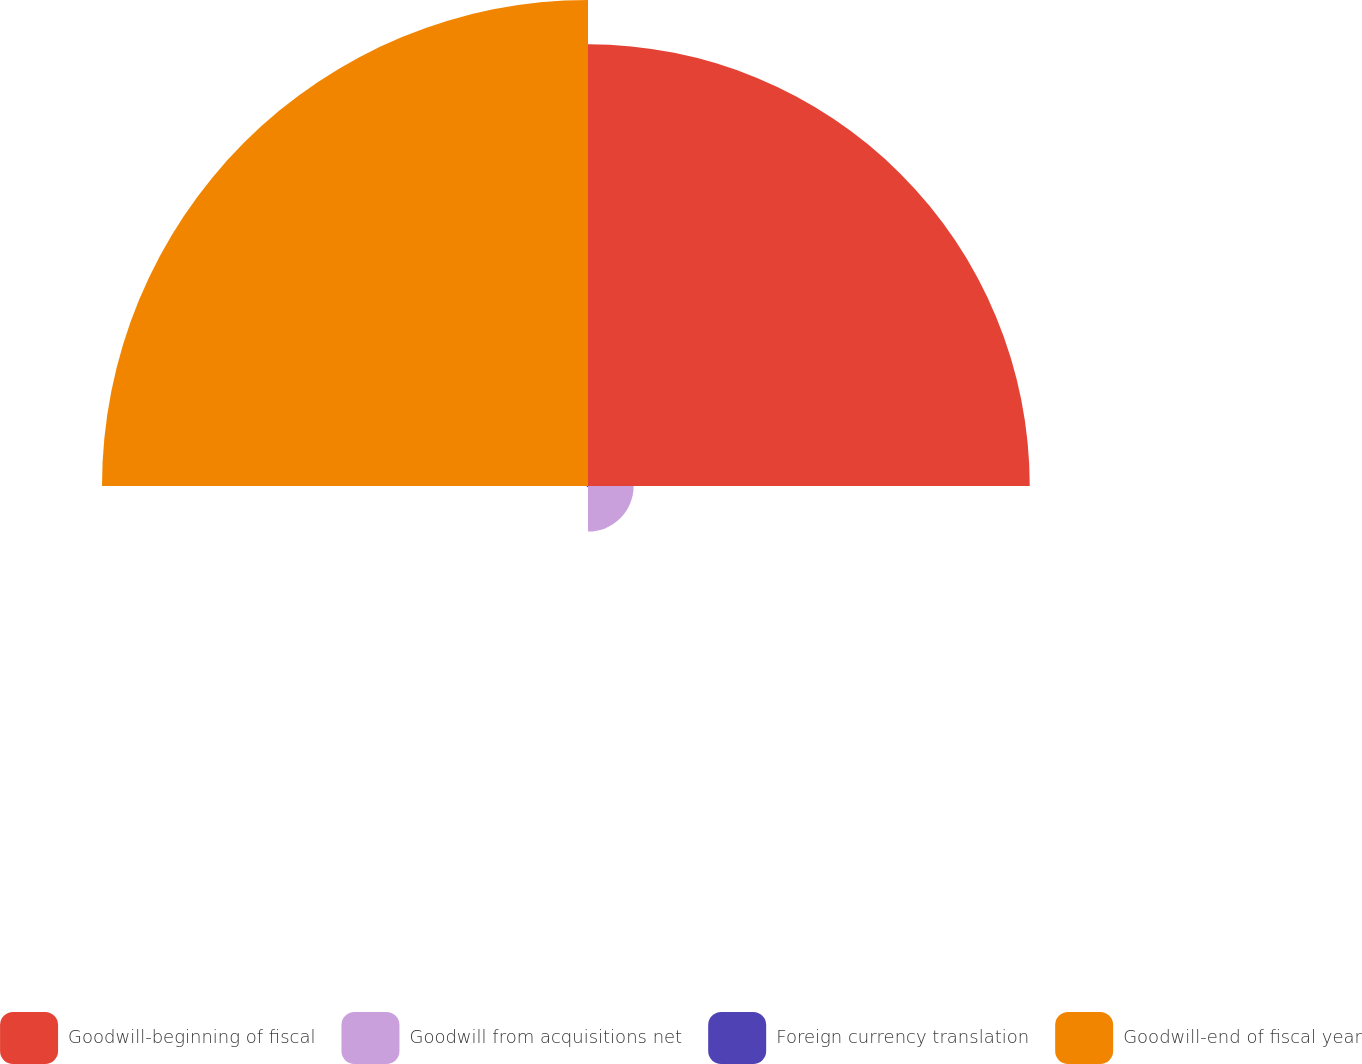<chart> <loc_0><loc_0><loc_500><loc_500><pie_chart><fcel>Goodwill-beginning of fiscal<fcel>Goodwill from acquisitions net<fcel>Foreign currency translation<fcel>Goodwill-end of fiscal year<nl><fcel>45.32%<fcel>4.68%<fcel>0.14%<fcel>49.86%<nl></chart> 